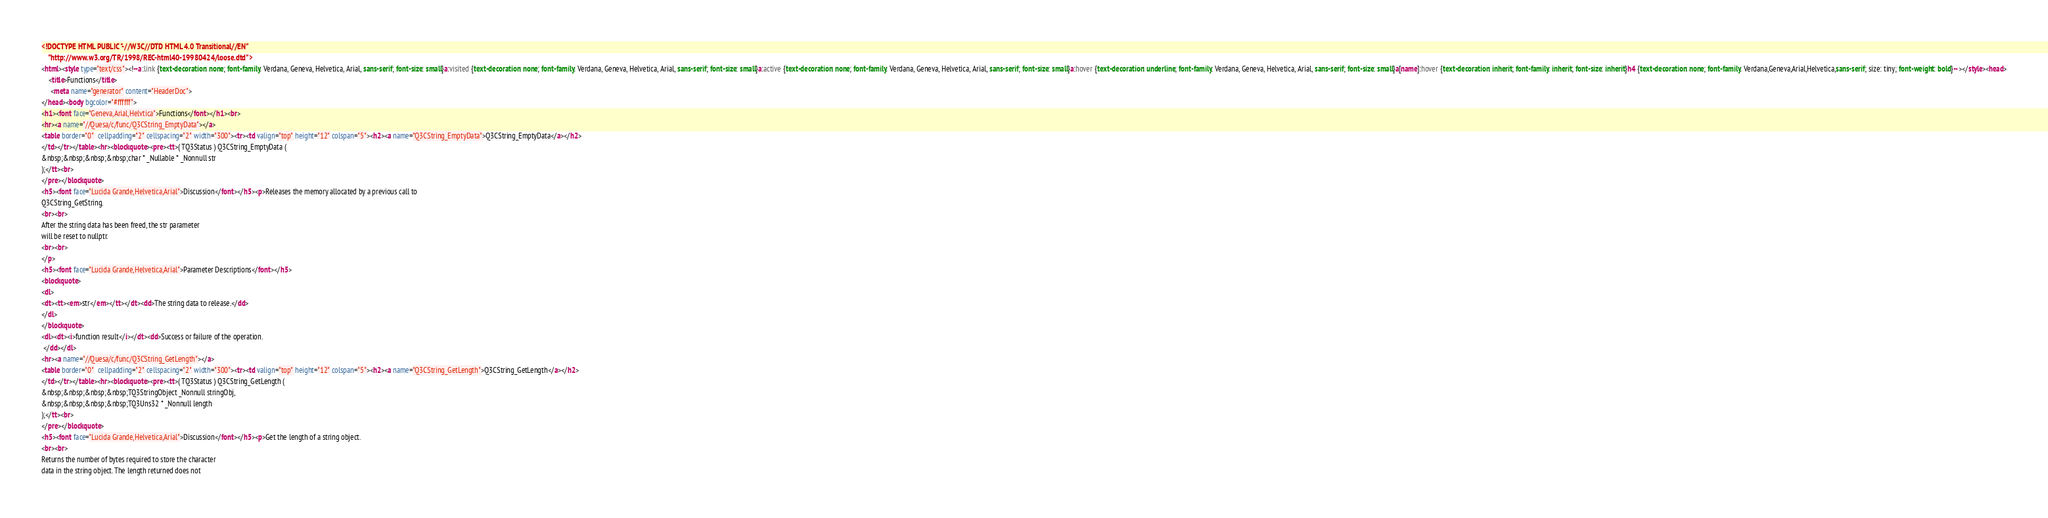Convert code to text. <code><loc_0><loc_0><loc_500><loc_500><_HTML_><!DOCTYPE HTML PUBLIC "-//W3C//DTD HTML 4.0 Transitional//EN"
    "http://www.w3.org/TR/1998/REC-html40-19980424/loose.dtd">
<html><style type="text/css"><!--a:link {text-decoration: none; font-family: Verdana, Geneva, Helvetica, Arial, sans-serif; font-size: small}a:visited {text-decoration: none; font-family: Verdana, Geneva, Helvetica, Arial, sans-serif; font-size: small}a:active {text-decoration: none; font-family: Verdana, Geneva, Helvetica, Arial, sans-serif; font-size: small}a:hover {text-decoration: underline; font-family: Verdana, Geneva, Helvetica, Arial, sans-serif; font-size: small}a[name]:hover {text-decoration: inherit; font-family: inherit; font-size: inherit}h4 {text-decoration: none; font-family: Verdana,Geneva,Arial,Helvetica,sans-serif; size: tiny; font-weight: bold}--></style><head>
    <title>Functions</title>
	 <meta name="generator" content="HeaderDoc">
</head><body bgcolor="#ffffff">
<h1><font face="Geneva,Arial,Helvtica">Functions</font></h1><br>
<hr><a name="//Quesa/c/func/Q3CString_EmptyData"></a>
<table border="0"  cellpadding="2" cellspacing="2" width="300"><tr><td valign="top" height="12" colspan="5"><h2><a name="Q3CString_EmptyData">Q3CString_EmptyData</a></h2>
</td></tr></table><hr><blockquote><pre><tt>( TQ3Status ) Q3CString_EmptyData (
&nbsp;&nbsp;&nbsp;&nbsp;char * _Nullable * _Nonnull str
);</tt><br>
</pre></blockquote>
<h5><font face="Lucida Grande,Helvetica,Arial">Discussion</font></h5><p>Releases the memory allocated by a previous call to
Q3CString_GetString.
<br><br>
After the string data has been freed, the str parameter
will be reset to nullptr.
<br><br>
</p>
<h5><font face="Lucida Grande,Helvetica,Arial">Parameter Descriptions</font></h5>
<blockquote>
<dl>
<dt><tt><em>str</em></tt></dt><dd>The string data to release.</dd>
</dl>
</blockquote>
<dl><dt><i>function result</i></dt><dd>Success or failure of the operation.
 </dd></dl>
<hr><a name="//Quesa/c/func/Q3CString_GetLength"></a>
<table border="0"  cellpadding="2" cellspacing="2" width="300"><tr><td valign="top" height="12" colspan="5"><h2><a name="Q3CString_GetLength">Q3CString_GetLength</a></h2>
</td></tr></table><hr><blockquote><pre><tt>( TQ3Status ) Q3CString_GetLength (
&nbsp;&nbsp;&nbsp;&nbsp;TQ3StringObject _Nonnull stringObj,
&nbsp;&nbsp;&nbsp;&nbsp;TQ3Uns32 * _Nonnull length
);</tt><br>
</pre></blockquote>
<h5><font face="Lucida Grande,Helvetica,Arial">Discussion</font></h5><p>Get the length of a string object.
<br><br>
Returns the number of bytes required to store the character
data in the string object. The length returned does not</code> 